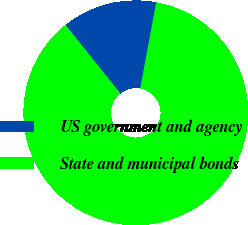Convert chart to OTSL. <chart><loc_0><loc_0><loc_500><loc_500><pie_chart><fcel>US government and agency<fcel>State and municipal bonds<nl><fcel>13.67%<fcel>86.33%<nl></chart> 